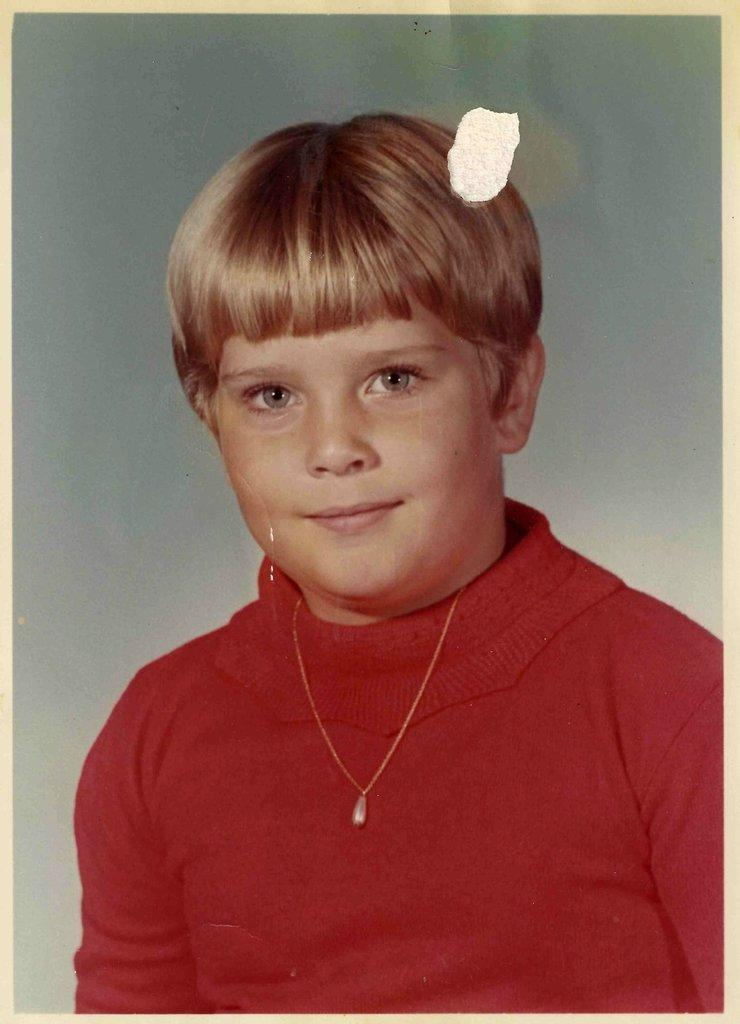What is present in the image? There is a person in the image. What is the person wearing? The person is wearing a red shirt. What is the person doing in the image? The person is posing for a photo. What type of gold jewelry can be seen on the person in the image? There is no gold jewelry visible on the person in the image; they are only wearing a red shirt. 